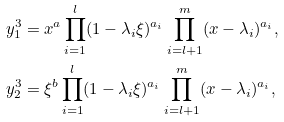<formula> <loc_0><loc_0><loc_500><loc_500>& y _ { 1 } ^ { 3 } = x ^ { a } \prod _ { i = 1 } ^ { l } ( 1 - \lambda _ { i } \xi ) ^ { a _ { i } } \prod _ { i = l + 1 } ^ { m } ( x - \lambda _ { i } ) ^ { a _ { i } } , \\ & y _ { 2 } ^ { 3 } = \xi ^ { b } \prod _ { i = 1 } ^ { l } ( 1 - \lambda _ { i } \xi ) ^ { a _ { i } } \prod _ { i = l + 1 } ^ { m } ( x - \lambda _ { i } ) ^ { a _ { i } } ,</formula> 